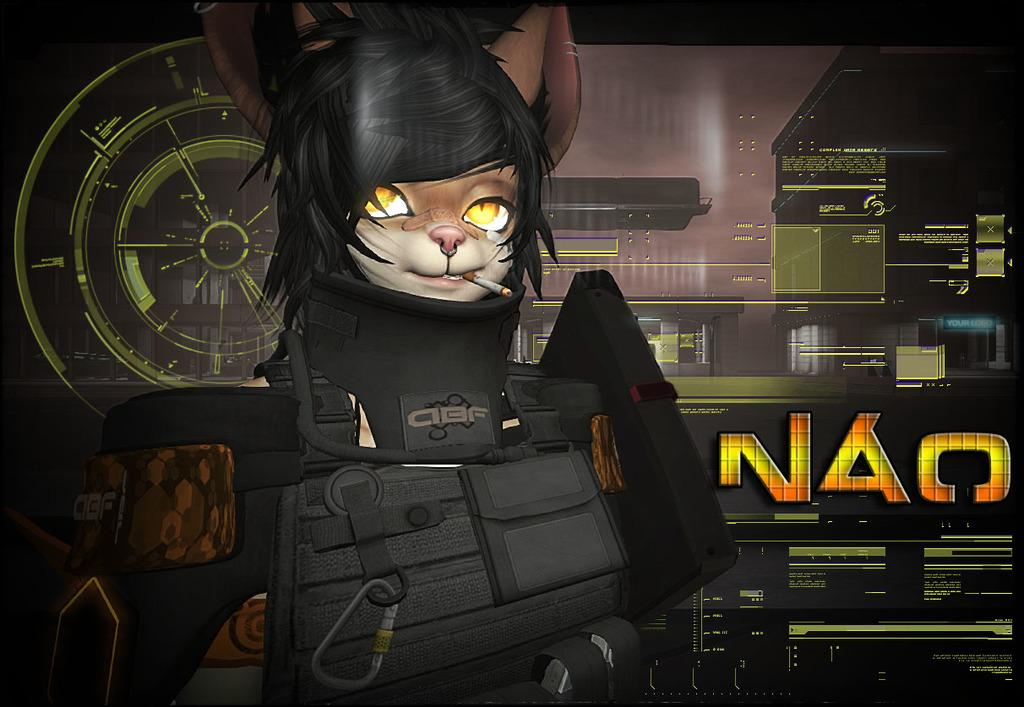What type of image is being described? The image is an animated picture. What is the main subject in the foreground of the image? There is a cat face anime in the foreground. What can be seen in the background of the image? There is a screen in the background. How many units are visible in the image? There is no mention of units in the image, so it cannot be determined from the provided facts. 